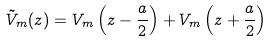<formula> <loc_0><loc_0><loc_500><loc_500>\tilde { V } _ { m } ( z ) = V _ { m } \left ( z - \frac { a } { 2 } \right ) + V _ { m } \left ( z + \frac { a } { 2 } \right )</formula> 